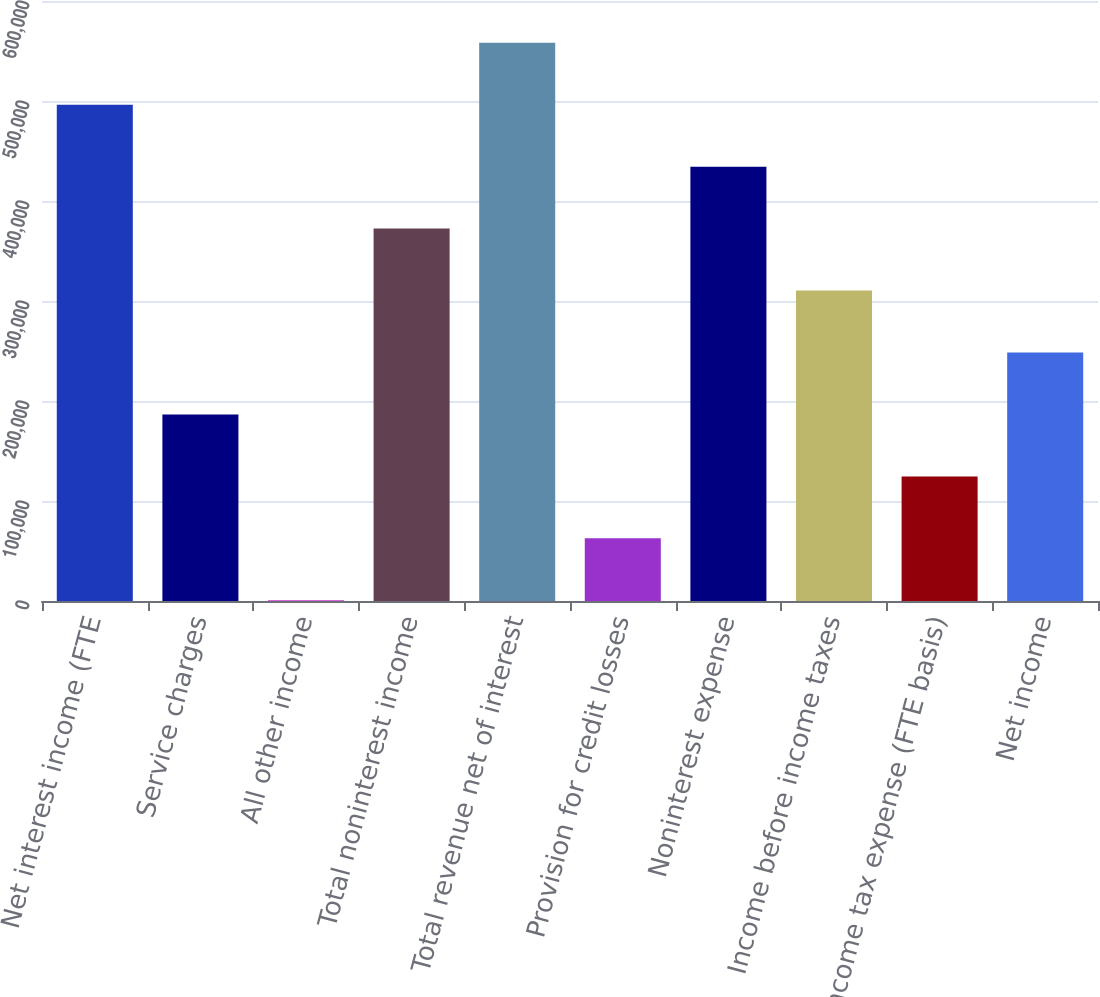Convert chart to OTSL. <chart><loc_0><loc_0><loc_500><loc_500><bar_chart><fcel>Net interest income (FTE<fcel>Service charges<fcel>All other income<fcel>Total noninterest income<fcel>Total revenue net of interest<fcel>Provision for credit losses<fcel>Noninterest expense<fcel>Income before income taxes<fcel>Income tax expense (FTE basis)<fcel>Net income<nl><fcel>496299<fcel>186566<fcel>727<fcel>372406<fcel>558246<fcel>62673.5<fcel>434352<fcel>310460<fcel>124620<fcel>248513<nl></chart> 